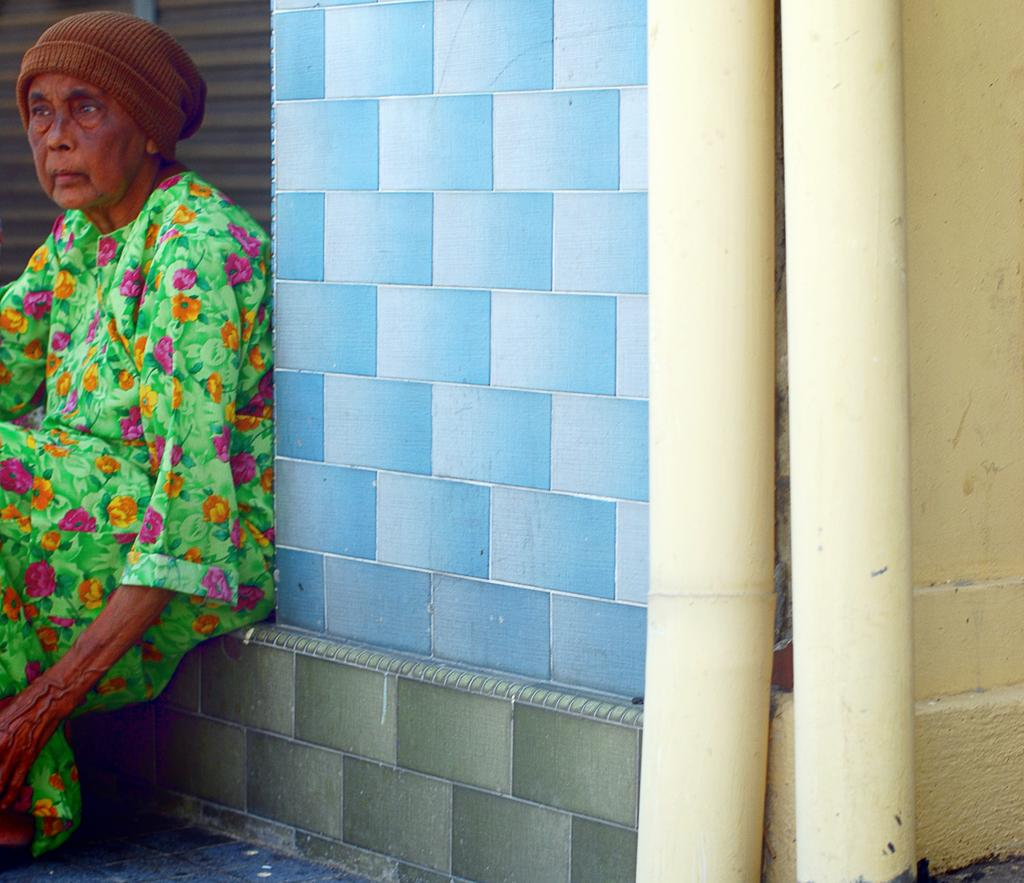What is the lady in the image doing? The lady is sitting in the image. What can be seen in the background of the image? There is a wall in the background of the image. What is located on the right side of the image? There are pipes on the right side of the image. What type of hook is hanging from the ceiling in the image? There is no hook hanging from the ceiling in the image. 